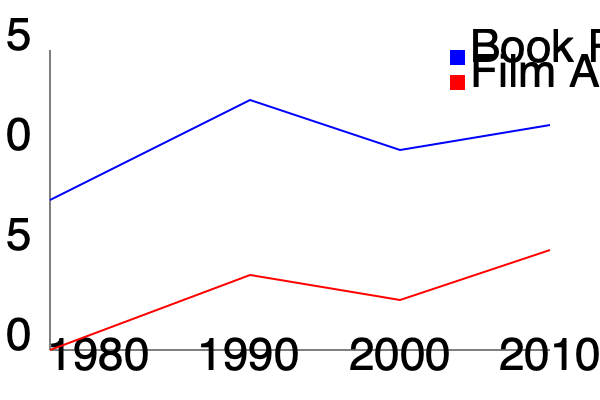Based on the dual-axis chart comparing the critical reception of Michael Ende's books to their film adaptations over time, what trend can be observed regarding the gap between book and adaptation reception from 1980 to 2010? To answer this question, we need to analyze the trends of both lines on the graph:

1. The blue line represents the critical reception of Michael Ende's books over time.
2. The red line represents the critical reception of film adaptations of Ende's works.

Let's examine the gap between these lines at different points:

1. 1980: 
   - Books: Around 7.5/15
   - Films: 0/15 (no adaptations yet)
   - Initial gap: Very large

2. 1990:
   - Books: About 12.5/15
   - Films: Around 3.75/15
   - Gap: Still large, but smaller than 1980

3. 2000:
   - Books: Approximately 10/15
   - Films: About 5/15
   - Gap: Smaller than in 1990

4. 2010:
   - Books: About 11.25/15
   - Films: Approximately 6.25/15
   - Gap: Smallest observed gap

Analyzing this trend, we can see that the gap between book and film adaptation reception has been consistently narrowing from 1980 to 2010. While the books maintain a higher reception throughout, the film adaptations have been gradually improving in critical reception, leading to a smaller difference between the two over time.
Answer: The gap between book and adaptation reception has narrowed over time. 